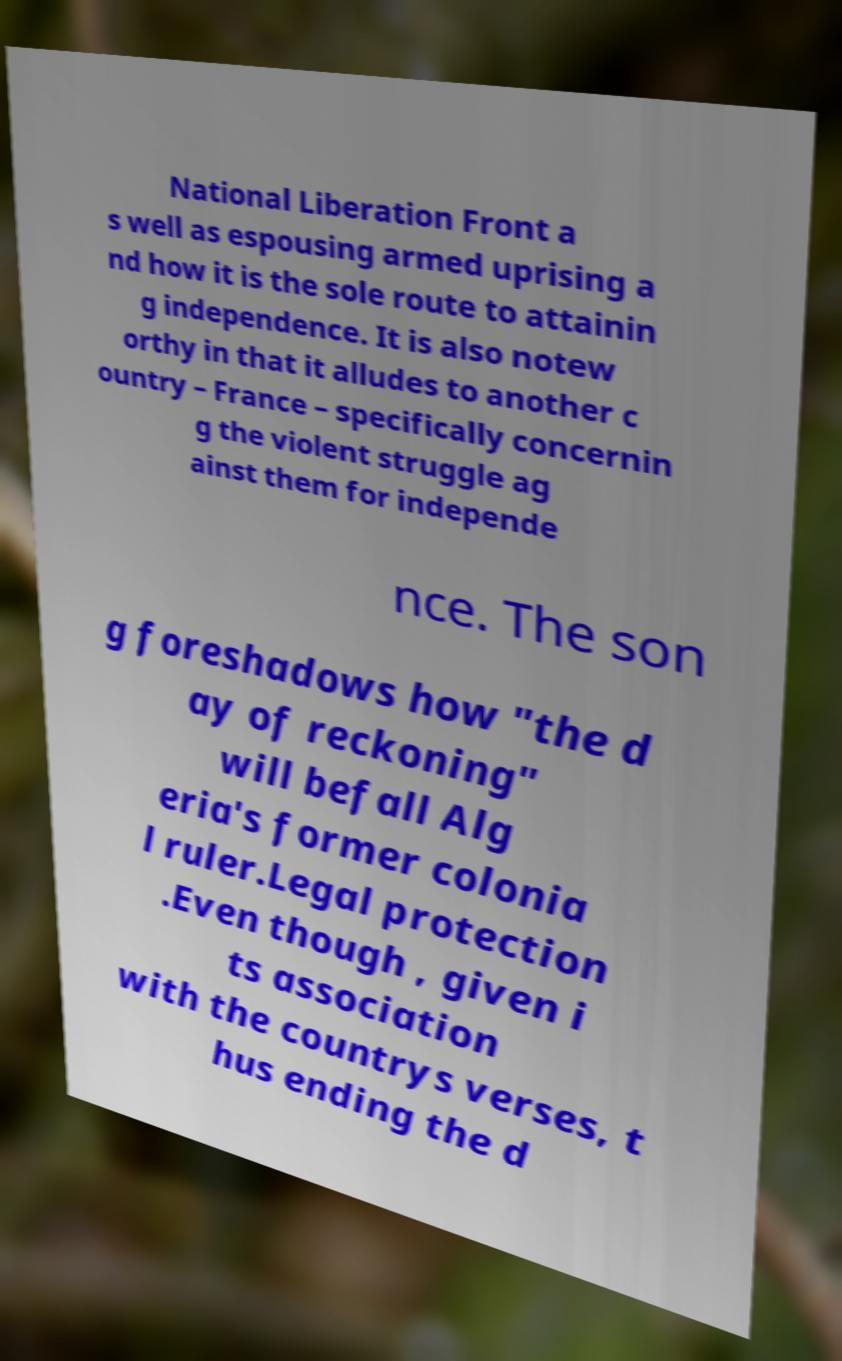Please identify and transcribe the text found in this image. National Liberation Front a s well as espousing armed uprising a nd how it is the sole route to attainin g independence. It is also notew orthy in that it alludes to another c ountry – France – specifically concernin g the violent struggle ag ainst them for independe nce. The son g foreshadows how "the d ay of reckoning" will befall Alg eria's former colonia l ruler.Legal protection .Even though , given i ts association with the countrys verses, t hus ending the d 